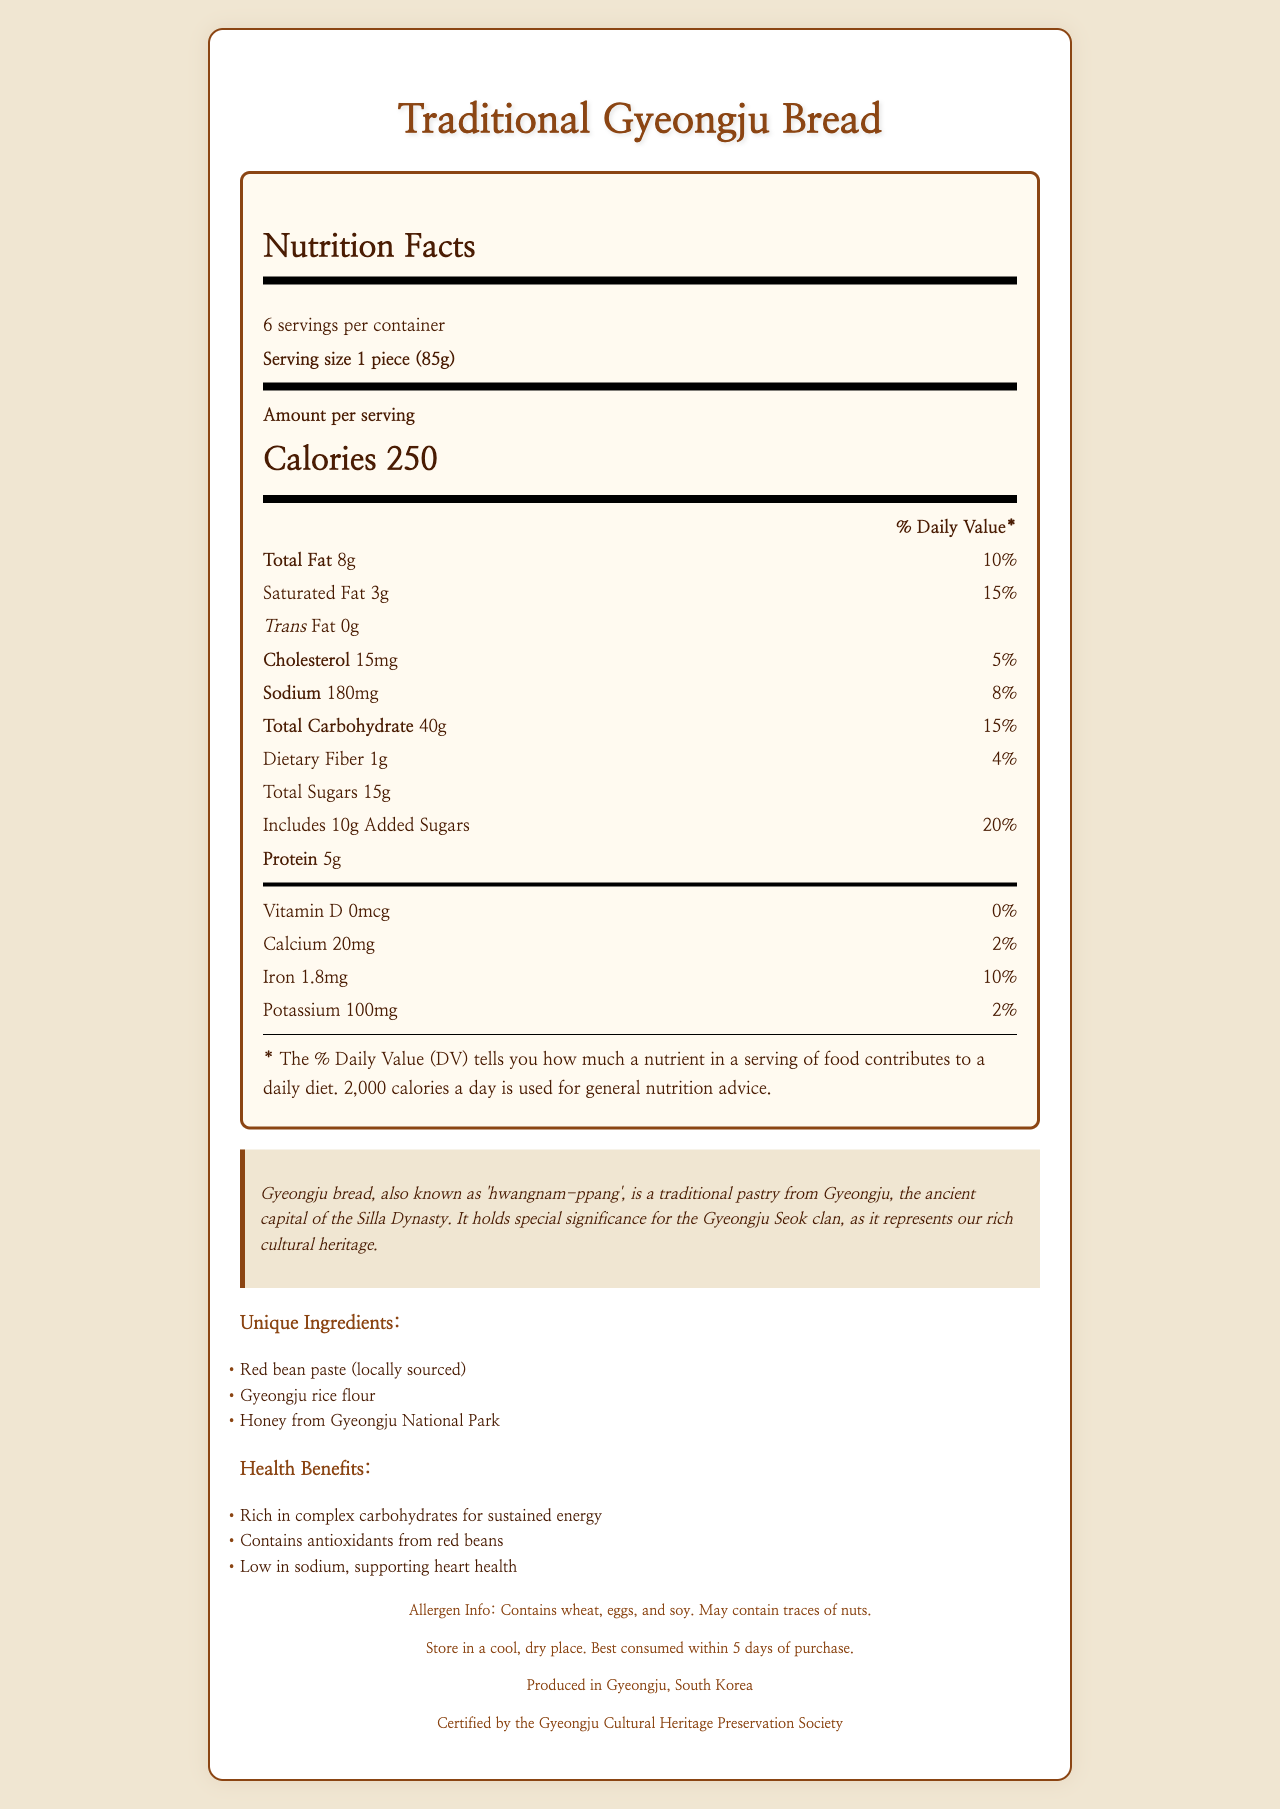what is the serving size for Traditional Gyeongju Bread? The serving size is clearly stated at the top of the Nutrition Facts label as "1 piece (85g)".
Answer: 1 piece (85g) how many calories are in one serving of Traditional Gyeongju Bread? The number of calories per serving is prominently displayed in bold and larger font in the Amount per Serving section.
Answer: 250 calories what are the unique ingredients in Traditional Gyeongju Bread? These ingredients are listed under the Unique Ingredients section.
Answer: Red bean paste (locally sourced), Gyeongju rice flour, Honey from Gyeongju National Park what percentage of the daily value of iron does one serving of Traditional Gyeongju Bread provide? The percentage of the daily value for iron is listed as 10% in the vitamins and minerals section at the bottom of the nutrition label.
Answer: 10% how much sodium does one serving of Traditional Gyeongju Bread contain? The amount of sodium per serving is listed as 180mg in the Nutrition Facts label.
Answer: 180mg which of the following health benefits is associated with Traditional Gyeongju Bread? A. High in protein B. Rich in Vitamin C C. Contains antioxidants from red beans D. High in fiber The Health Benefits section mentions that the product contains antioxidants from red beans.
Answer: C what allergens are present in Traditional Gyeongju Bread? A. Milk, wheat, and soy B. Wheat, eggs, and soy C. Peanuts, tree nuts, and soy D. Eggs, milk, and peanuts The Allergen Info at the bottom of the document specifies that it contains wheat, eggs, and soy.
Answer: B is Traditional Gyeongju Bread certified by a cultural heritage society? The document states that it is certified by the Gyeongju Cultural Heritage Preservation Society.
Answer: Yes describe the main idea of the document The document offers comprehensive information about Traditional Gyeongju Bread, combining both its cultural context and nutritional details.
Answer: The document provides detailed nutrition facts, cultural significance, unique ingredients, health benefits, allergen info, storage instructions, and manufacturing location of Traditional Gyeongju Bread. It emphasizes the bread's rich cultural heritage linked to the Gyeongju Seok clan and highlights its nutritional profile. how much Vitamin D does one serving of Traditional Gyeongju Bread contain? The Vitamin D amount per serving is listed as 0mcg in the vitamins and minerals section at the bottom of the nutrition label.
Answer: 0mcg what is the cultural significance of Traditional Gyeongju Bread for the Gyeongju Seok clan? This information is provided under the Cultural Significance section of the document.
Answer: Gyeongju bread represents the rich cultural heritage of the Gyeongju Seok clan and is a traditional pastry from Gyeongju, the ancient capital of the Silla Dynasty. how many servings are there per container for Traditional Gyeongju Bread? A. 4 B. 5 C. 6 D. 8 The document specifies that there are 6 servings per container.
Answer: C what type of fat is absent in Traditional Gyeongju Bread? It is indicated in the nutrition label that the amount of trans fat is 0g.
Answer: Trans fat how should Traditional Gyeongju Bread be stored? This storage instruction is listed at the bottom of the document.
Answer: Store in a cool, dry place. Best consumed within 5 days of purchase. where is Traditional Gyeongju Bread produced? The document mentions that it is produced in Gyeongju, South Korea, in the footer section.
Answer: Gyeongju, South Korea what sacred temple in Gyeongju is depicted on the packaging? The document does not provide any information about sacred temples being depicted on the packaging.
Answer: Not enough information 